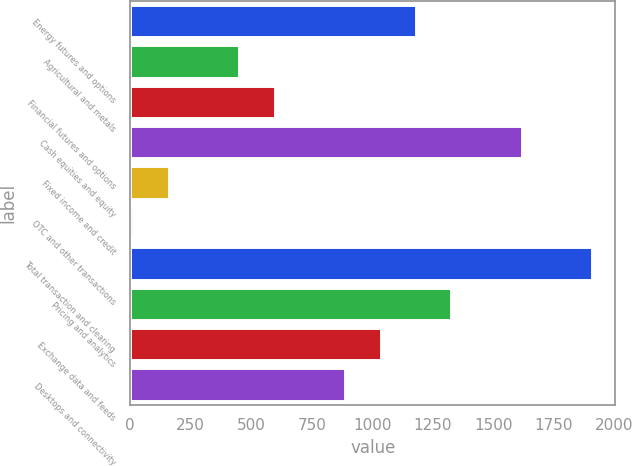Convert chart. <chart><loc_0><loc_0><loc_500><loc_500><bar_chart><fcel>Energy futures and options<fcel>Agricultural and metals<fcel>Financial futures and options<fcel>Cash equities and equity<fcel>Fixed income and credit<fcel>OTC and other transactions<fcel>Total transaction and clearing<fcel>Pricing and analytics<fcel>Exchange data and feeds<fcel>Desktops and connectivity<nl><fcel>1179.4<fcel>450.4<fcel>596.2<fcel>1616.8<fcel>158.8<fcel>13<fcel>1908.4<fcel>1325.2<fcel>1033.6<fcel>887.8<nl></chart> 